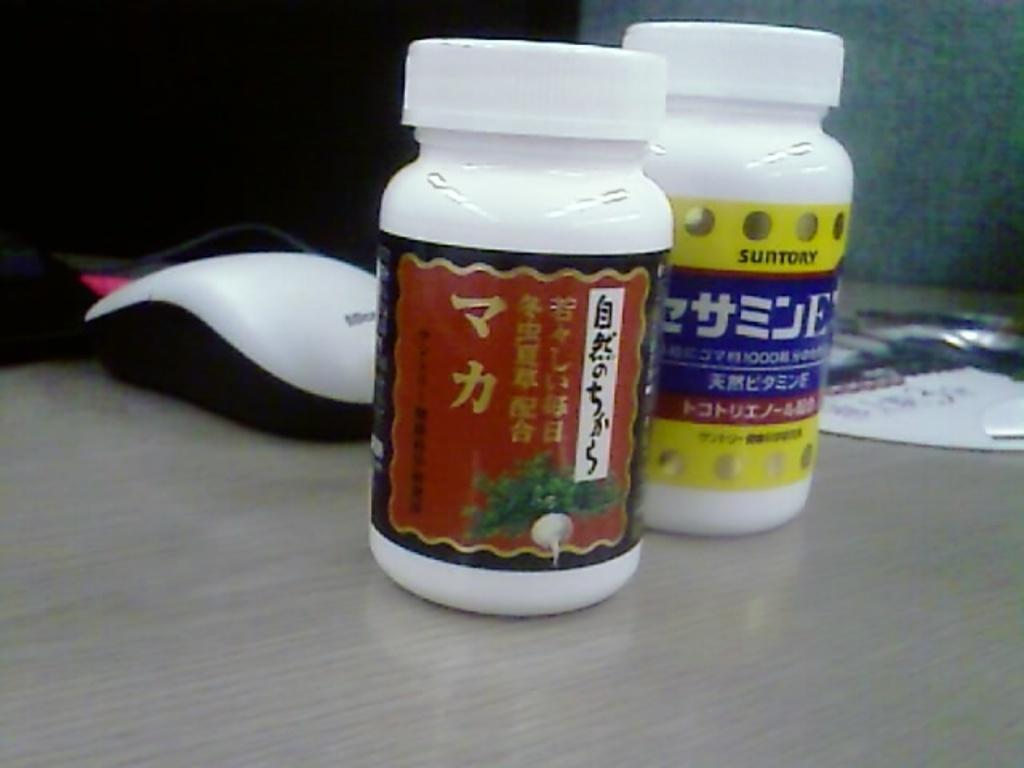In one or two sentences, can you explain what this image depicts? In this image i can see a table ,on the table there is a mouse , and there are some bottles kept on the table and there a label attached to the bottle and some text written on that label 